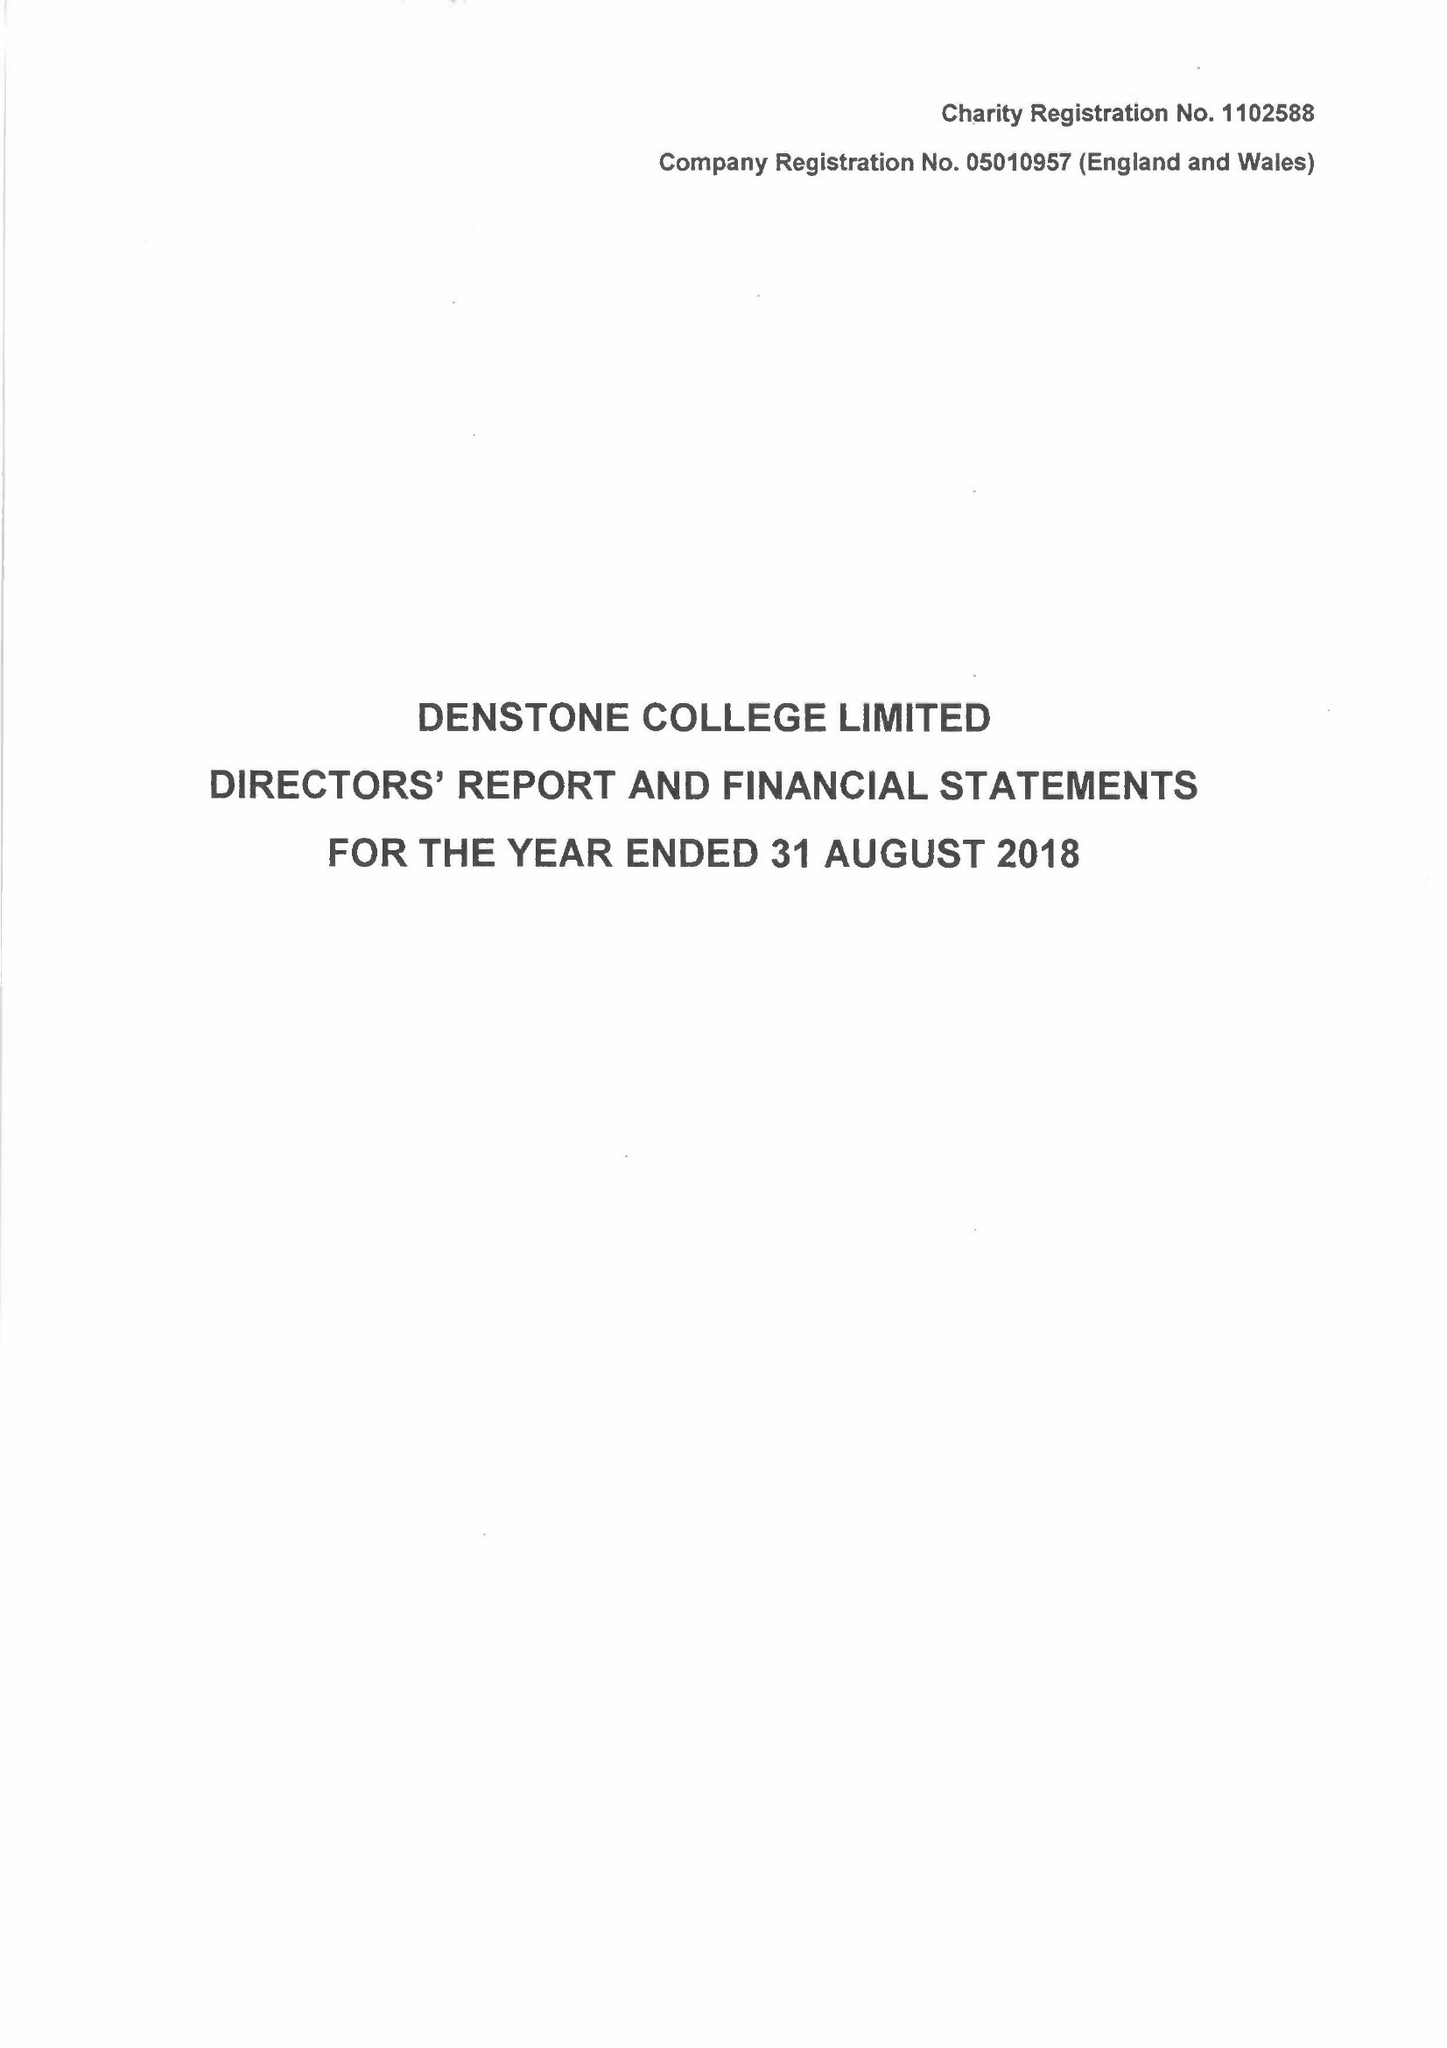What is the value for the address__post_town?
Answer the question using a single word or phrase. UTTOXETER 